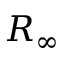Convert formula to latex. <formula><loc_0><loc_0><loc_500><loc_500>R _ { \infty }</formula> 